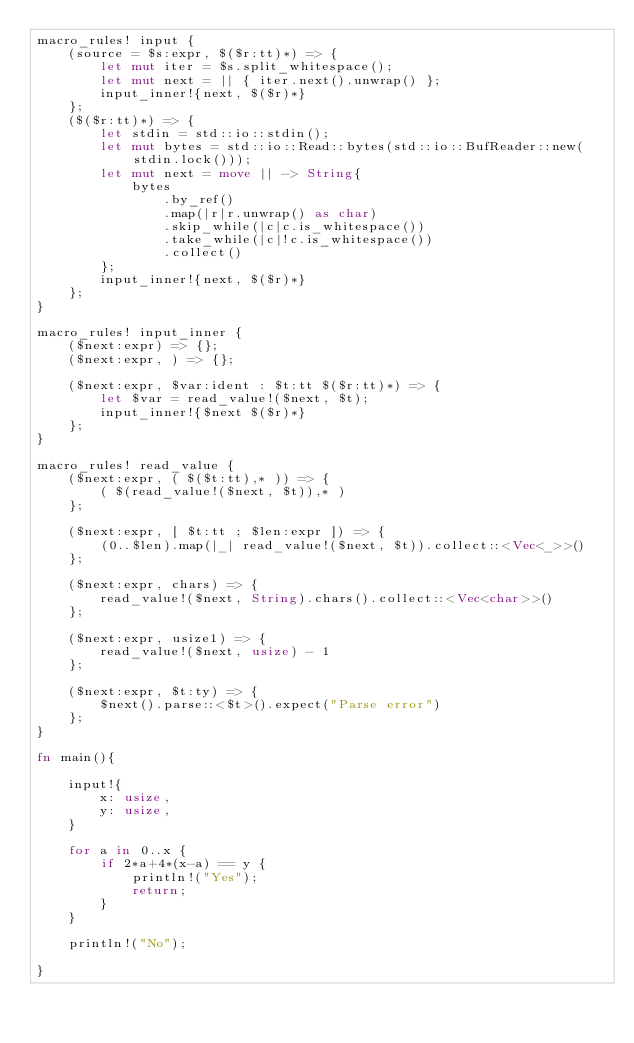<code> <loc_0><loc_0><loc_500><loc_500><_Rust_>macro_rules! input {
    (source = $s:expr, $($r:tt)*) => {
        let mut iter = $s.split_whitespace();
        let mut next = || { iter.next().unwrap() };
        input_inner!{next, $($r)*}
    };
    ($($r:tt)*) => {
        let stdin = std::io::stdin();
        let mut bytes = std::io::Read::bytes(std::io::BufReader::new(stdin.lock()));
        let mut next = move || -> String{
            bytes
                .by_ref()
                .map(|r|r.unwrap() as char)
                .skip_while(|c|c.is_whitespace())
                .take_while(|c|!c.is_whitespace())
                .collect()
        };
        input_inner!{next, $($r)*}
    };
}

macro_rules! input_inner {
    ($next:expr) => {};
    ($next:expr, ) => {};

    ($next:expr, $var:ident : $t:tt $($r:tt)*) => {
        let $var = read_value!($next, $t);
        input_inner!{$next $($r)*}
    };
}

macro_rules! read_value {
    ($next:expr, ( $($t:tt),* )) => {
        ( $(read_value!($next, $t)),* )
    };

    ($next:expr, [ $t:tt ; $len:expr ]) => {
        (0..$len).map(|_| read_value!($next, $t)).collect::<Vec<_>>()
    };

    ($next:expr, chars) => {
        read_value!($next, String).chars().collect::<Vec<char>>()
    };

    ($next:expr, usize1) => {
        read_value!($next, usize) - 1
    };

    ($next:expr, $t:ty) => {
        $next().parse::<$t>().expect("Parse error")
    };
}

fn main(){

    input!{
        x: usize,
        y: usize,
    }

    for a in 0..x {
        if 2*a+4*(x-a) == y {
            println!("Yes");
            return;
        }
    }

    println!("No");

}</code> 